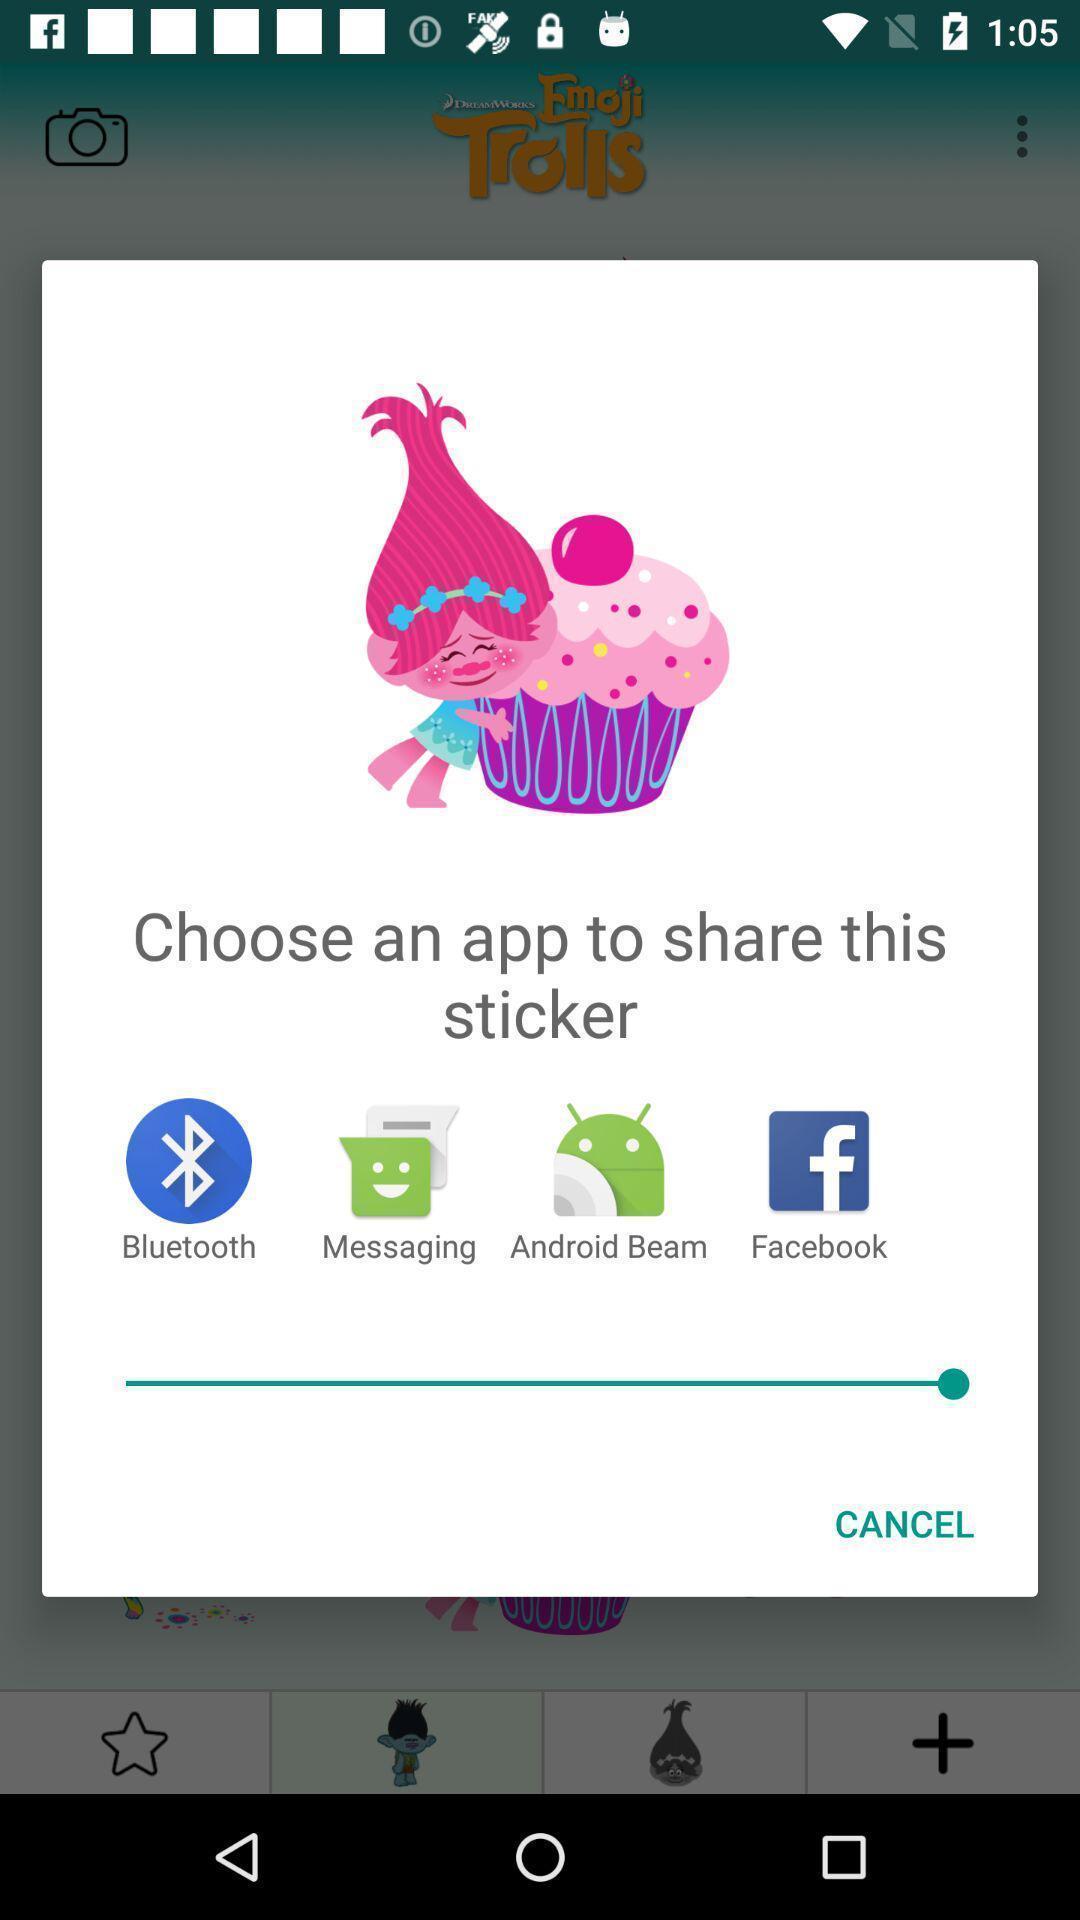Explain what's happening in this screen capture. Pop-up to share sticker via different apps. 